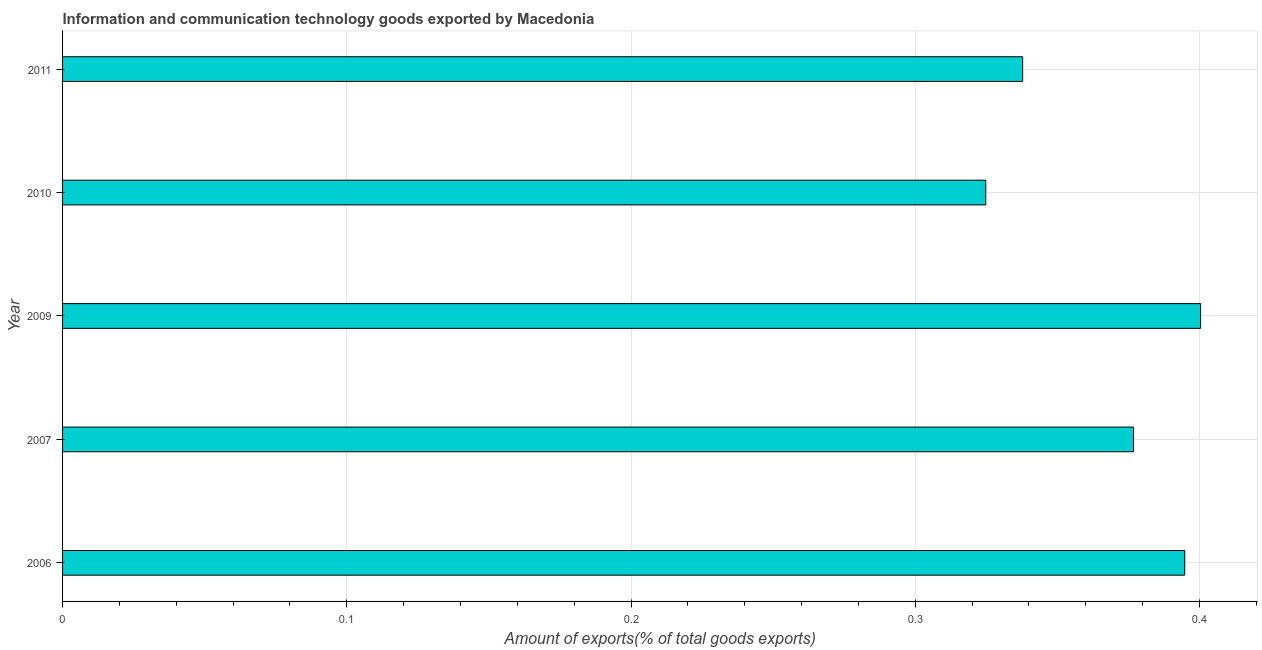Does the graph contain grids?
Provide a succinct answer. Yes. What is the title of the graph?
Offer a terse response. Information and communication technology goods exported by Macedonia. What is the label or title of the X-axis?
Provide a succinct answer. Amount of exports(% of total goods exports). What is the label or title of the Y-axis?
Offer a very short reply. Year. What is the amount of ict goods exports in 2010?
Give a very brief answer. 0.32. Across all years, what is the maximum amount of ict goods exports?
Offer a terse response. 0.4. Across all years, what is the minimum amount of ict goods exports?
Offer a terse response. 0.32. In which year was the amount of ict goods exports minimum?
Your answer should be compact. 2010. What is the sum of the amount of ict goods exports?
Keep it short and to the point. 1.83. What is the difference between the amount of ict goods exports in 2006 and 2007?
Offer a very short reply. 0.02. What is the average amount of ict goods exports per year?
Make the answer very short. 0.37. What is the median amount of ict goods exports?
Ensure brevity in your answer.  0.38. In how many years, is the amount of ict goods exports greater than 0.06 %?
Ensure brevity in your answer.  5. Do a majority of the years between 2010 and 2007 (inclusive) have amount of ict goods exports greater than 0.3 %?
Offer a very short reply. Yes. What is the ratio of the amount of ict goods exports in 2007 to that in 2010?
Provide a short and direct response. 1.16. Is the amount of ict goods exports in 2009 less than that in 2010?
Offer a very short reply. No. What is the difference between the highest and the second highest amount of ict goods exports?
Your answer should be compact. 0.01. Is the sum of the amount of ict goods exports in 2007 and 2009 greater than the maximum amount of ict goods exports across all years?
Your response must be concise. Yes. How many bars are there?
Provide a succinct answer. 5. Are all the bars in the graph horizontal?
Offer a very short reply. Yes. How many years are there in the graph?
Keep it short and to the point. 5. What is the difference between two consecutive major ticks on the X-axis?
Keep it short and to the point. 0.1. What is the Amount of exports(% of total goods exports) in 2006?
Ensure brevity in your answer.  0.39. What is the Amount of exports(% of total goods exports) in 2007?
Offer a very short reply. 0.38. What is the Amount of exports(% of total goods exports) of 2009?
Provide a short and direct response. 0.4. What is the Amount of exports(% of total goods exports) in 2010?
Ensure brevity in your answer.  0.32. What is the Amount of exports(% of total goods exports) in 2011?
Offer a terse response. 0.34. What is the difference between the Amount of exports(% of total goods exports) in 2006 and 2007?
Offer a very short reply. 0.02. What is the difference between the Amount of exports(% of total goods exports) in 2006 and 2009?
Your response must be concise. -0.01. What is the difference between the Amount of exports(% of total goods exports) in 2006 and 2010?
Give a very brief answer. 0.07. What is the difference between the Amount of exports(% of total goods exports) in 2006 and 2011?
Offer a terse response. 0.06. What is the difference between the Amount of exports(% of total goods exports) in 2007 and 2009?
Give a very brief answer. -0.02. What is the difference between the Amount of exports(% of total goods exports) in 2007 and 2010?
Your answer should be very brief. 0.05. What is the difference between the Amount of exports(% of total goods exports) in 2007 and 2011?
Ensure brevity in your answer.  0.04. What is the difference between the Amount of exports(% of total goods exports) in 2009 and 2010?
Your answer should be compact. 0.08. What is the difference between the Amount of exports(% of total goods exports) in 2009 and 2011?
Keep it short and to the point. 0.06. What is the difference between the Amount of exports(% of total goods exports) in 2010 and 2011?
Provide a short and direct response. -0.01. What is the ratio of the Amount of exports(% of total goods exports) in 2006 to that in 2007?
Ensure brevity in your answer.  1.05. What is the ratio of the Amount of exports(% of total goods exports) in 2006 to that in 2009?
Ensure brevity in your answer.  0.99. What is the ratio of the Amount of exports(% of total goods exports) in 2006 to that in 2010?
Provide a short and direct response. 1.22. What is the ratio of the Amount of exports(% of total goods exports) in 2006 to that in 2011?
Your answer should be compact. 1.17. What is the ratio of the Amount of exports(% of total goods exports) in 2007 to that in 2009?
Your response must be concise. 0.94. What is the ratio of the Amount of exports(% of total goods exports) in 2007 to that in 2010?
Offer a terse response. 1.16. What is the ratio of the Amount of exports(% of total goods exports) in 2007 to that in 2011?
Your answer should be very brief. 1.11. What is the ratio of the Amount of exports(% of total goods exports) in 2009 to that in 2010?
Offer a terse response. 1.23. What is the ratio of the Amount of exports(% of total goods exports) in 2009 to that in 2011?
Your answer should be compact. 1.19. 